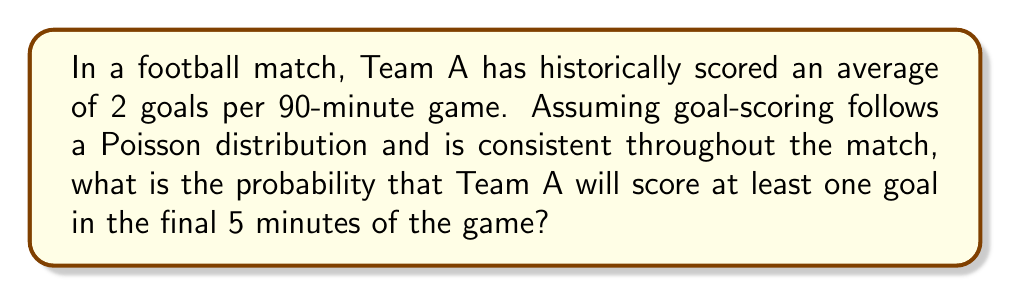Could you help me with this problem? Let's approach this step-by-step:

1) First, we need to calculate the average number of goals scored in 5 minutes.
   If 2 goals are scored in 90 minutes on average, then in 5 minutes:
   $\lambda = 2 * (5/90) = 1/9 \approx 0.1111$

2) We're using the Poisson distribution, where the probability of x events occurring in a given interval is:

   $P(X = x) = \frac{e^{-\lambda}\lambda^x}{x!}$

3) We want the probability of scoring at least one goal, which is the same as 1 minus the probability of scoring zero goals:

   $P(X \geq 1) = 1 - P(X = 0)$

4) Let's calculate $P(X = 0)$:

   $P(X = 0) = \frac{e^{-0.1111}(0.1111)^0}{0!} = e^{-0.1111} \approx 0.8948$

5) Therefore, the probability of scoring at least one goal is:

   $P(X \geq 1) = 1 - 0.8948 \approx 0.1052$

6) Converting to a percentage: $0.1052 * 100 \approx 10.52\%$
Answer: $10.52\%$ 